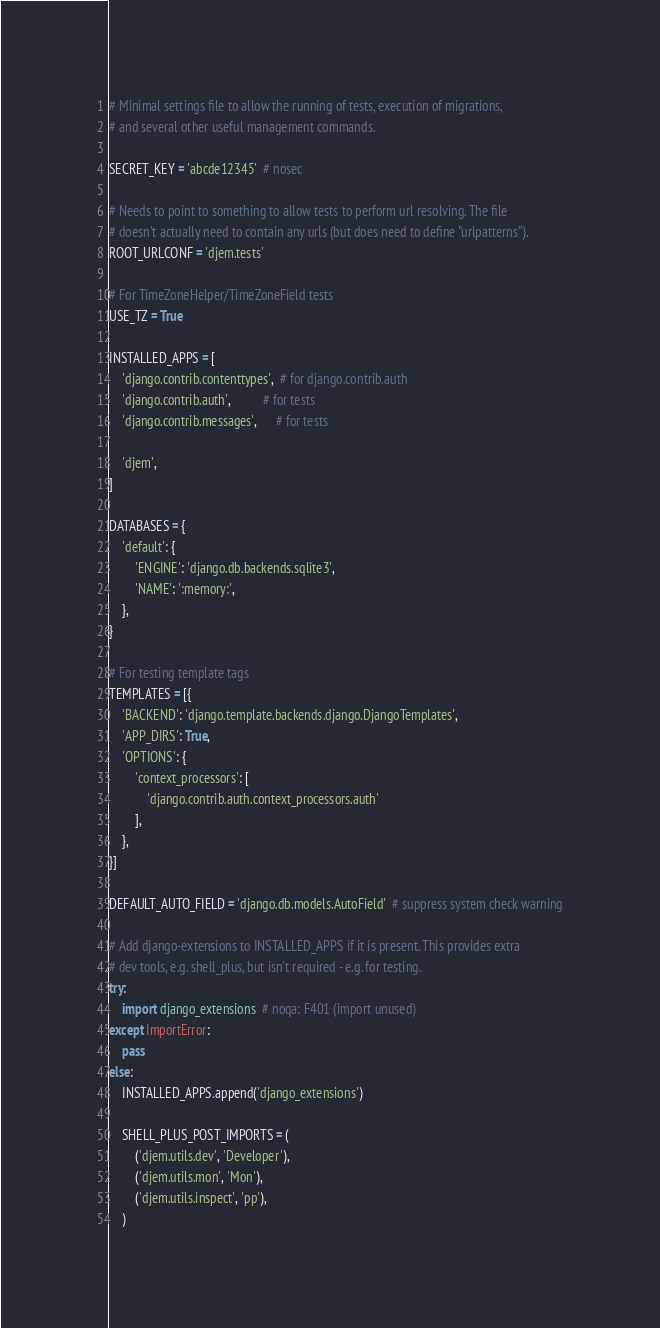<code> <loc_0><loc_0><loc_500><loc_500><_Python_># Minimal settings file to allow the running of tests, execution of migrations,
# and several other useful management commands.

SECRET_KEY = 'abcde12345'  # nosec

# Needs to point to something to allow tests to perform url resolving. The file
# doesn't actually need to contain any urls (but does need to define "urlpatterns").
ROOT_URLCONF = 'djem.tests'

# For TimeZoneHelper/TimeZoneField tests
USE_TZ = True

INSTALLED_APPS = [
    'django.contrib.contenttypes',  # for django.contrib.auth
    'django.contrib.auth',          # for tests
    'django.contrib.messages',      # for tests
    
    'djem',
]

DATABASES = {
    'default': {
        'ENGINE': 'django.db.backends.sqlite3',
        'NAME': ':memory:',
    },
}

# For testing template tags
TEMPLATES = [{
    'BACKEND': 'django.template.backends.django.DjangoTemplates',
    'APP_DIRS': True,
    'OPTIONS': {
        'context_processors': [
            'django.contrib.auth.context_processors.auth'
        ],
    },
}]

DEFAULT_AUTO_FIELD = 'django.db.models.AutoField'  # suppress system check warning

# Add django-extensions to INSTALLED_APPS if it is present. This provides extra
# dev tools, e.g. shell_plus, but isn't required - e.g. for testing.
try:
    import django_extensions  # noqa: F401 (import unused)
except ImportError:
    pass
else:
    INSTALLED_APPS.append('django_extensions')
    
    SHELL_PLUS_POST_IMPORTS = (
        ('djem.utils.dev', 'Developer'),
        ('djem.utils.mon', 'Mon'),
        ('djem.utils.inspect', 'pp'),
    )
</code> 